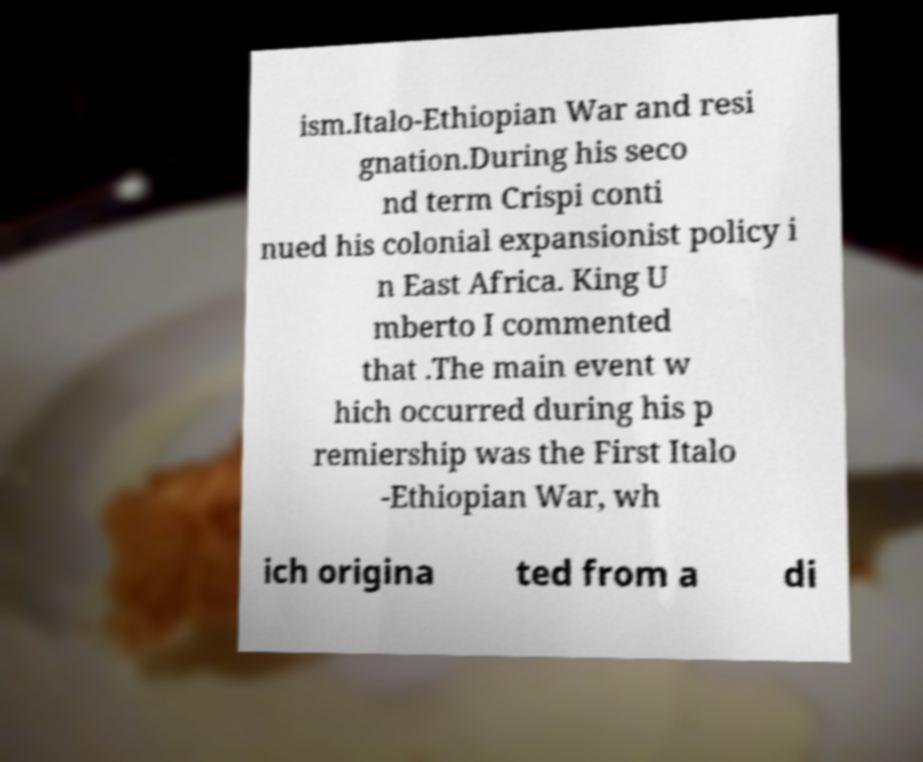Could you assist in decoding the text presented in this image and type it out clearly? ism.Italo-Ethiopian War and resi gnation.During his seco nd term Crispi conti nued his colonial expansionist policy i n East Africa. King U mberto I commented that .The main event w hich occurred during his p remiership was the First Italo -Ethiopian War, wh ich origina ted from a di 